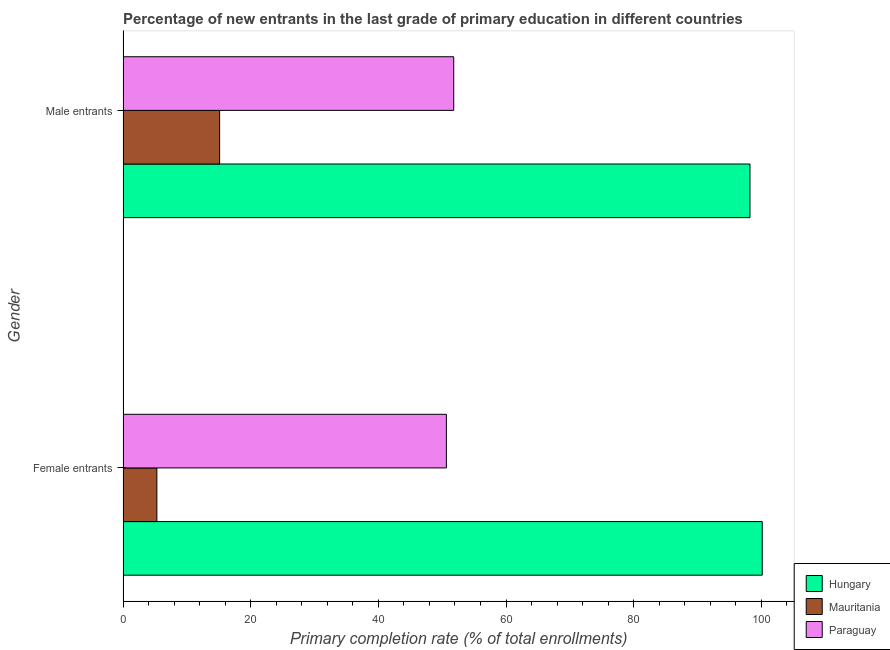How many different coloured bars are there?
Keep it short and to the point. 3. How many groups of bars are there?
Offer a very short reply. 2. Are the number of bars per tick equal to the number of legend labels?
Ensure brevity in your answer.  Yes. Are the number of bars on each tick of the Y-axis equal?
Your response must be concise. Yes. What is the label of the 2nd group of bars from the top?
Make the answer very short. Female entrants. What is the primary completion rate of male entrants in Paraguay?
Offer a very short reply. 51.81. Across all countries, what is the maximum primary completion rate of female entrants?
Provide a succinct answer. 100.14. Across all countries, what is the minimum primary completion rate of male entrants?
Your answer should be compact. 15.14. In which country was the primary completion rate of male entrants maximum?
Provide a succinct answer. Hungary. In which country was the primary completion rate of female entrants minimum?
Give a very brief answer. Mauritania. What is the total primary completion rate of female entrants in the graph?
Your response must be concise. 156.1. What is the difference between the primary completion rate of female entrants in Hungary and that in Mauritania?
Your answer should be compact. 94.83. What is the difference between the primary completion rate of male entrants in Hungary and the primary completion rate of female entrants in Paraguay?
Offer a terse response. 47.56. What is the average primary completion rate of male entrants per country?
Give a very brief answer. 55.05. What is the difference between the primary completion rate of male entrants and primary completion rate of female entrants in Hungary?
Your answer should be very brief. -1.92. In how many countries, is the primary completion rate of male entrants greater than 72 %?
Make the answer very short. 1. What is the ratio of the primary completion rate of female entrants in Mauritania to that in Paraguay?
Offer a very short reply. 0.1. Is the primary completion rate of male entrants in Mauritania less than that in Hungary?
Keep it short and to the point. Yes. What does the 3rd bar from the top in Female entrants represents?
Offer a very short reply. Hungary. What does the 1st bar from the bottom in Female entrants represents?
Make the answer very short. Hungary. How many bars are there?
Your answer should be compact. 6. Are all the bars in the graph horizontal?
Ensure brevity in your answer.  Yes. What is the difference between two consecutive major ticks on the X-axis?
Provide a short and direct response. 20. Does the graph contain grids?
Provide a short and direct response. No. How many legend labels are there?
Your response must be concise. 3. How are the legend labels stacked?
Give a very brief answer. Vertical. What is the title of the graph?
Offer a terse response. Percentage of new entrants in the last grade of primary education in different countries. What is the label or title of the X-axis?
Offer a very short reply. Primary completion rate (% of total enrollments). What is the label or title of the Y-axis?
Your answer should be very brief. Gender. What is the Primary completion rate (% of total enrollments) in Hungary in Female entrants?
Make the answer very short. 100.14. What is the Primary completion rate (% of total enrollments) in Mauritania in Female entrants?
Make the answer very short. 5.31. What is the Primary completion rate (% of total enrollments) of Paraguay in Female entrants?
Ensure brevity in your answer.  50.65. What is the Primary completion rate (% of total enrollments) in Hungary in Male entrants?
Your answer should be very brief. 98.22. What is the Primary completion rate (% of total enrollments) of Mauritania in Male entrants?
Your answer should be very brief. 15.14. What is the Primary completion rate (% of total enrollments) in Paraguay in Male entrants?
Offer a very short reply. 51.81. Across all Gender, what is the maximum Primary completion rate (% of total enrollments) of Hungary?
Give a very brief answer. 100.14. Across all Gender, what is the maximum Primary completion rate (% of total enrollments) in Mauritania?
Keep it short and to the point. 15.14. Across all Gender, what is the maximum Primary completion rate (% of total enrollments) in Paraguay?
Make the answer very short. 51.81. Across all Gender, what is the minimum Primary completion rate (% of total enrollments) of Hungary?
Provide a succinct answer. 98.22. Across all Gender, what is the minimum Primary completion rate (% of total enrollments) of Mauritania?
Keep it short and to the point. 5.31. Across all Gender, what is the minimum Primary completion rate (% of total enrollments) in Paraguay?
Offer a very short reply. 50.65. What is the total Primary completion rate (% of total enrollments) of Hungary in the graph?
Keep it short and to the point. 198.35. What is the total Primary completion rate (% of total enrollments) in Mauritania in the graph?
Your answer should be very brief. 20.44. What is the total Primary completion rate (% of total enrollments) of Paraguay in the graph?
Provide a succinct answer. 102.46. What is the difference between the Primary completion rate (% of total enrollments) in Hungary in Female entrants and that in Male entrants?
Provide a succinct answer. 1.92. What is the difference between the Primary completion rate (% of total enrollments) in Mauritania in Female entrants and that in Male entrants?
Keep it short and to the point. -9.83. What is the difference between the Primary completion rate (% of total enrollments) of Paraguay in Female entrants and that in Male entrants?
Provide a succinct answer. -1.15. What is the difference between the Primary completion rate (% of total enrollments) in Hungary in Female entrants and the Primary completion rate (% of total enrollments) in Mauritania in Male entrants?
Your answer should be compact. 85. What is the difference between the Primary completion rate (% of total enrollments) in Hungary in Female entrants and the Primary completion rate (% of total enrollments) in Paraguay in Male entrants?
Give a very brief answer. 48.33. What is the difference between the Primary completion rate (% of total enrollments) in Mauritania in Female entrants and the Primary completion rate (% of total enrollments) in Paraguay in Male entrants?
Give a very brief answer. -46.5. What is the average Primary completion rate (% of total enrollments) of Hungary per Gender?
Your answer should be compact. 99.18. What is the average Primary completion rate (% of total enrollments) in Mauritania per Gender?
Ensure brevity in your answer.  10.22. What is the average Primary completion rate (% of total enrollments) of Paraguay per Gender?
Offer a very short reply. 51.23. What is the difference between the Primary completion rate (% of total enrollments) of Hungary and Primary completion rate (% of total enrollments) of Mauritania in Female entrants?
Ensure brevity in your answer.  94.83. What is the difference between the Primary completion rate (% of total enrollments) of Hungary and Primary completion rate (% of total enrollments) of Paraguay in Female entrants?
Make the answer very short. 49.48. What is the difference between the Primary completion rate (% of total enrollments) of Mauritania and Primary completion rate (% of total enrollments) of Paraguay in Female entrants?
Make the answer very short. -45.35. What is the difference between the Primary completion rate (% of total enrollments) of Hungary and Primary completion rate (% of total enrollments) of Mauritania in Male entrants?
Offer a very short reply. 83.08. What is the difference between the Primary completion rate (% of total enrollments) of Hungary and Primary completion rate (% of total enrollments) of Paraguay in Male entrants?
Your response must be concise. 46.41. What is the difference between the Primary completion rate (% of total enrollments) in Mauritania and Primary completion rate (% of total enrollments) in Paraguay in Male entrants?
Keep it short and to the point. -36.67. What is the ratio of the Primary completion rate (% of total enrollments) of Hungary in Female entrants to that in Male entrants?
Your answer should be very brief. 1.02. What is the ratio of the Primary completion rate (% of total enrollments) in Mauritania in Female entrants to that in Male entrants?
Your answer should be very brief. 0.35. What is the ratio of the Primary completion rate (% of total enrollments) of Paraguay in Female entrants to that in Male entrants?
Ensure brevity in your answer.  0.98. What is the difference between the highest and the second highest Primary completion rate (% of total enrollments) in Hungary?
Provide a short and direct response. 1.92. What is the difference between the highest and the second highest Primary completion rate (% of total enrollments) in Mauritania?
Your answer should be compact. 9.83. What is the difference between the highest and the second highest Primary completion rate (% of total enrollments) of Paraguay?
Your response must be concise. 1.15. What is the difference between the highest and the lowest Primary completion rate (% of total enrollments) of Hungary?
Provide a short and direct response. 1.92. What is the difference between the highest and the lowest Primary completion rate (% of total enrollments) of Mauritania?
Keep it short and to the point. 9.83. What is the difference between the highest and the lowest Primary completion rate (% of total enrollments) of Paraguay?
Your response must be concise. 1.15. 